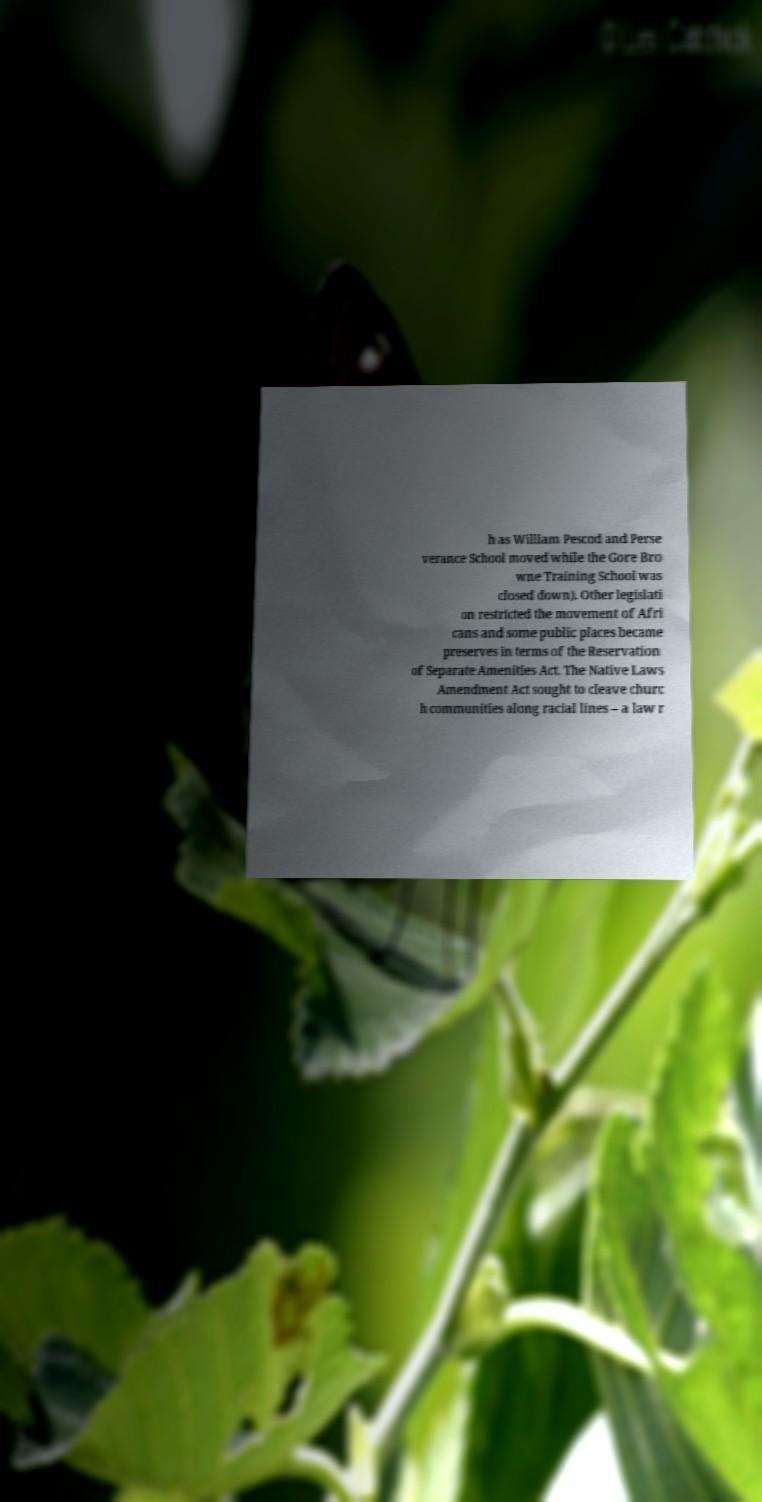Could you extract and type out the text from this image? h as William Pescod and Perse verance School moved while the Gore Bro wne Training School was closed down). Other legislati on restricted the movement of Afri cans and some public places became preserves in terms of the Reservation of Separate Amenities Act. The Native Laws Amendment Act sought to cleave churc h communities along racial lines – a law r 